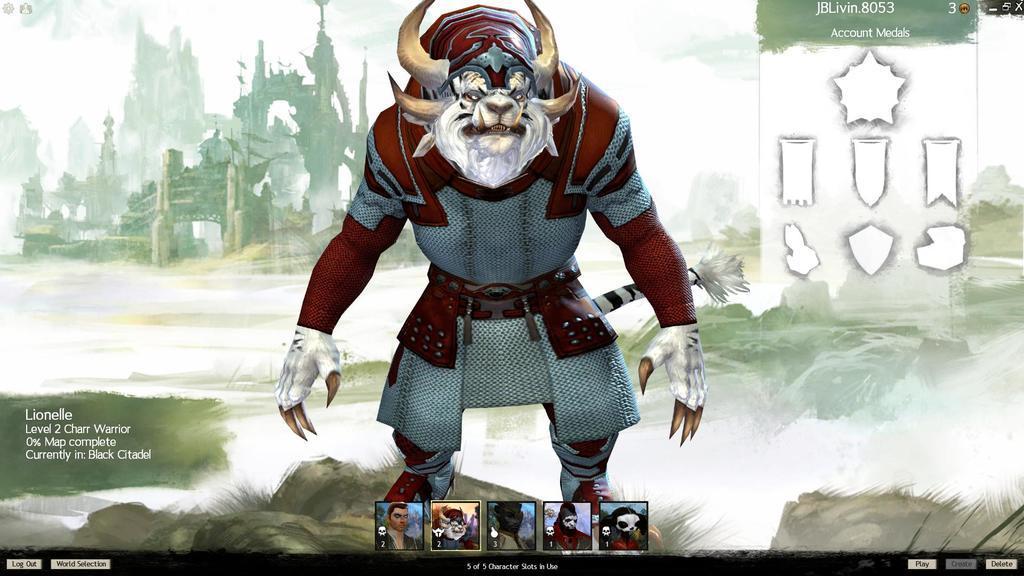Describe this image in one or two sentences. This is an animated image of the cartoon pictures. We can also see a building, sky, some pictures and text on this image. 